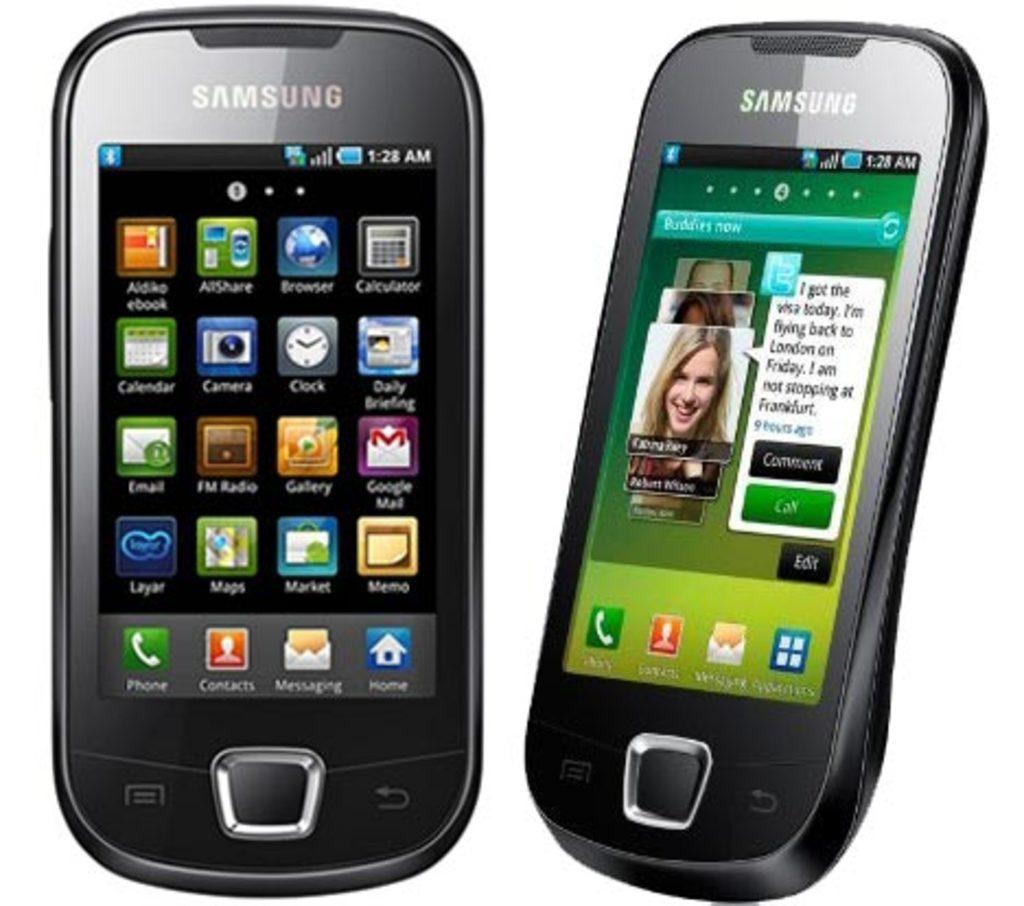What brand is this phone?
Your response must be concise. Samsung. What is the app with a person on an orange icon for?
Provide a succinct answer. Contacts. 